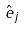Convert formula to latex. <formula><loc_0><loc_0><loc_500><loc_500>\hat { e } _ { j }</formula> 